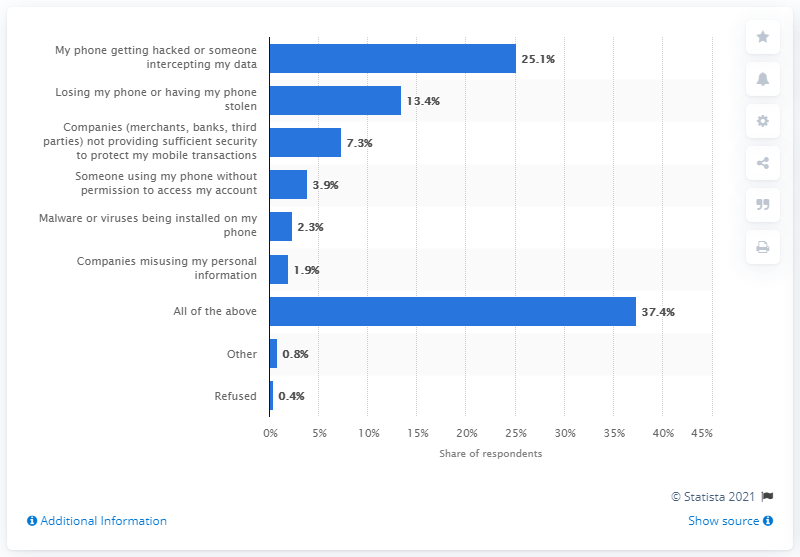Draw attention to some important aspects in this diagram. According to a recent survey, 25.1% of U.S. adults reported being afraid of having their phone hacked. 